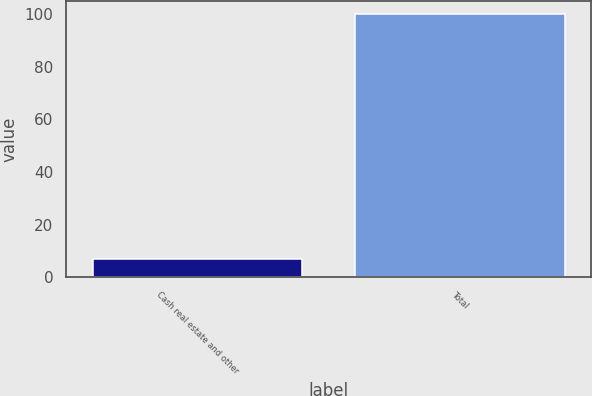Convert chart. <chart><loc_0><loc_0><loc_500><loc_500><bar_chart><fcel>Cash real estate and other<fcel>Total<nl><fcel>7<fcel>100<nl></chart> 